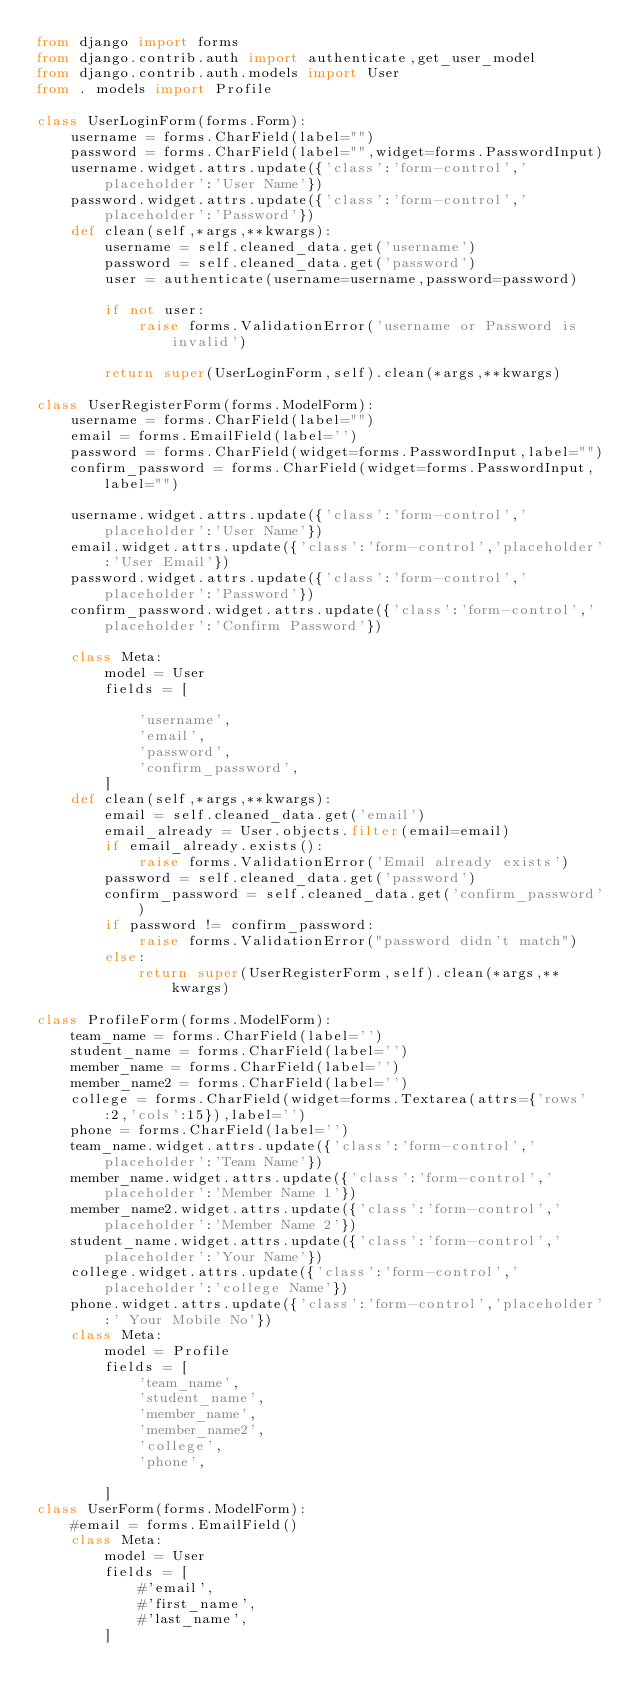Convert code to text. <code><loc_0><loc_0><loc_500><loc_500><_Python_>from django import forms
from django.contrib.auth import authenticate,get_user_model
from django.contrib.auth.models import User
from . models import Profile

class UserLoginForm(forms.Form):
    username = forms.CharField(label="")
    password = forms.CharField(label="",widget=forms.PasswordInput)
    username.widget.attrs.update({'class':'form-control','placeholder':'User Name'})
    password.widget.attrs.update({'class':'form-control','placeholder':'Password'})
    def clean(self,*args,**kwargs):
        username = self.cleaned_data.get('username')
        password = self.cleaned_data.get('password')
        user = authenticate(username=username,password=password)

        if not user:
            raise forms.ValidationError('username or Password is invalid')

        return super(UserLoginForm,self).clean(*args,**kwargs)

class UserRegisterForm(forms.ModelForm):
    username = forms.CharField(label="")
    email = forms.EmailField(label='')
    password = forms.CharField(widget=forms.PasswordInput,label="")
    confirm_password = forms.CharField(widget=forms.PasswordInput,label="")

    username.widget.attrs.update({'class':'form-control','placeholder':'User Name'})
    email.widget.attrs.update({'class':'form-control','placeholder':'User Email'})
    password.widget.attrs.update({'class':'form-control','placeholder':'Password'})
    confirm_password.widget.attrs.update({'class':'form-control','placeholder':'Confirm Password'})

    class Meta:
        model = User
        fields = [

            'username',
            'email',
            'password',
            'confirm_password',
        ]
    def clean(self,*args,**kwargs):
        email = self.cleaned_data.get('email')
        email_already = User.objects.filter(email=email)
        if email_already.exists():
            raise forms.ValidationError('Email already exists')
        password = self.cleaned_data.get('password')
        confirm_password = self.cleaned_data.get('confirm_password')
        if password != confirm_password:
            raise forms.ValidationError("password didn't match")
        else:
            return super(UserRegisterForm,self).clean(*args,**kwargs)

class ProfileForm(forms.ModelForm):
    team_name = forms.CharField(label='')
    student_name = forms.CharField(label='')
    member_name = forms.CharField(label='')
    member_name2 = forms.CharField(label='')
    college = forms.CharField(widget=forms.Textarea(attrs={'rows':2,'cols':15}),label='')
    phone = forms.CharField(label='')
    team_name.widget.attrs.update({'class':'form-control','placeholder':'Team Name'})
    member_name.widget.attrs.update({'class':'form-control','placeholder':'Member Name 1'})
    member_name2.widget.attrs.update({'class':'form-control','placeholder':'Member Name 2'})
    student_name.widget.attrs.update({'class':'form-control','placeholder':'Your Name'})
    college.widget.attrs.update({'class':'form-control','placeholder':'college Name'})
    phone.widget.attrs.update({'class':'form-control','placeholder':' Your Mobile No'})
    class Meta:
        model = Profile
        fields = [
            'team_name',
            'student_name',
            'member_name',
            'member_name2',
            'college',
            'phone',

        ]
class UserForm(forms.ModelForm):
    #email = forms.EmailField()
    class Meta:
        model = User
        fields = [
            #'email',
            #'first_name',
            #'last_name',
        ]
</code> 